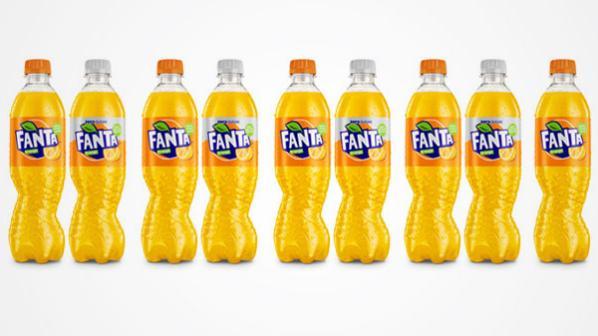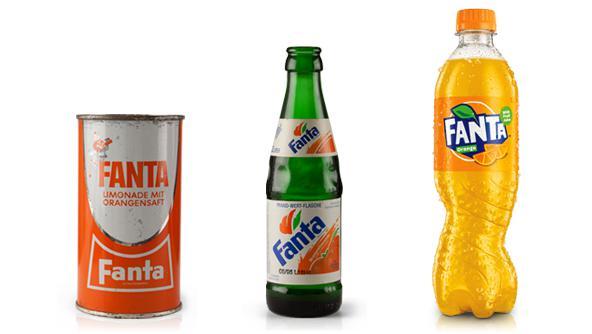The first image is the image on the left, the second image is the image on the right. Assess this claim about the two images: "One of the images includes fewer than three drink containers.". Correct or not? Answer yes or no. No. The first image is the image on the left, the second image is the image on the right. Given the left and right images, does the statement "All the containers are plastic." hold true? Answer yes or no. No. 